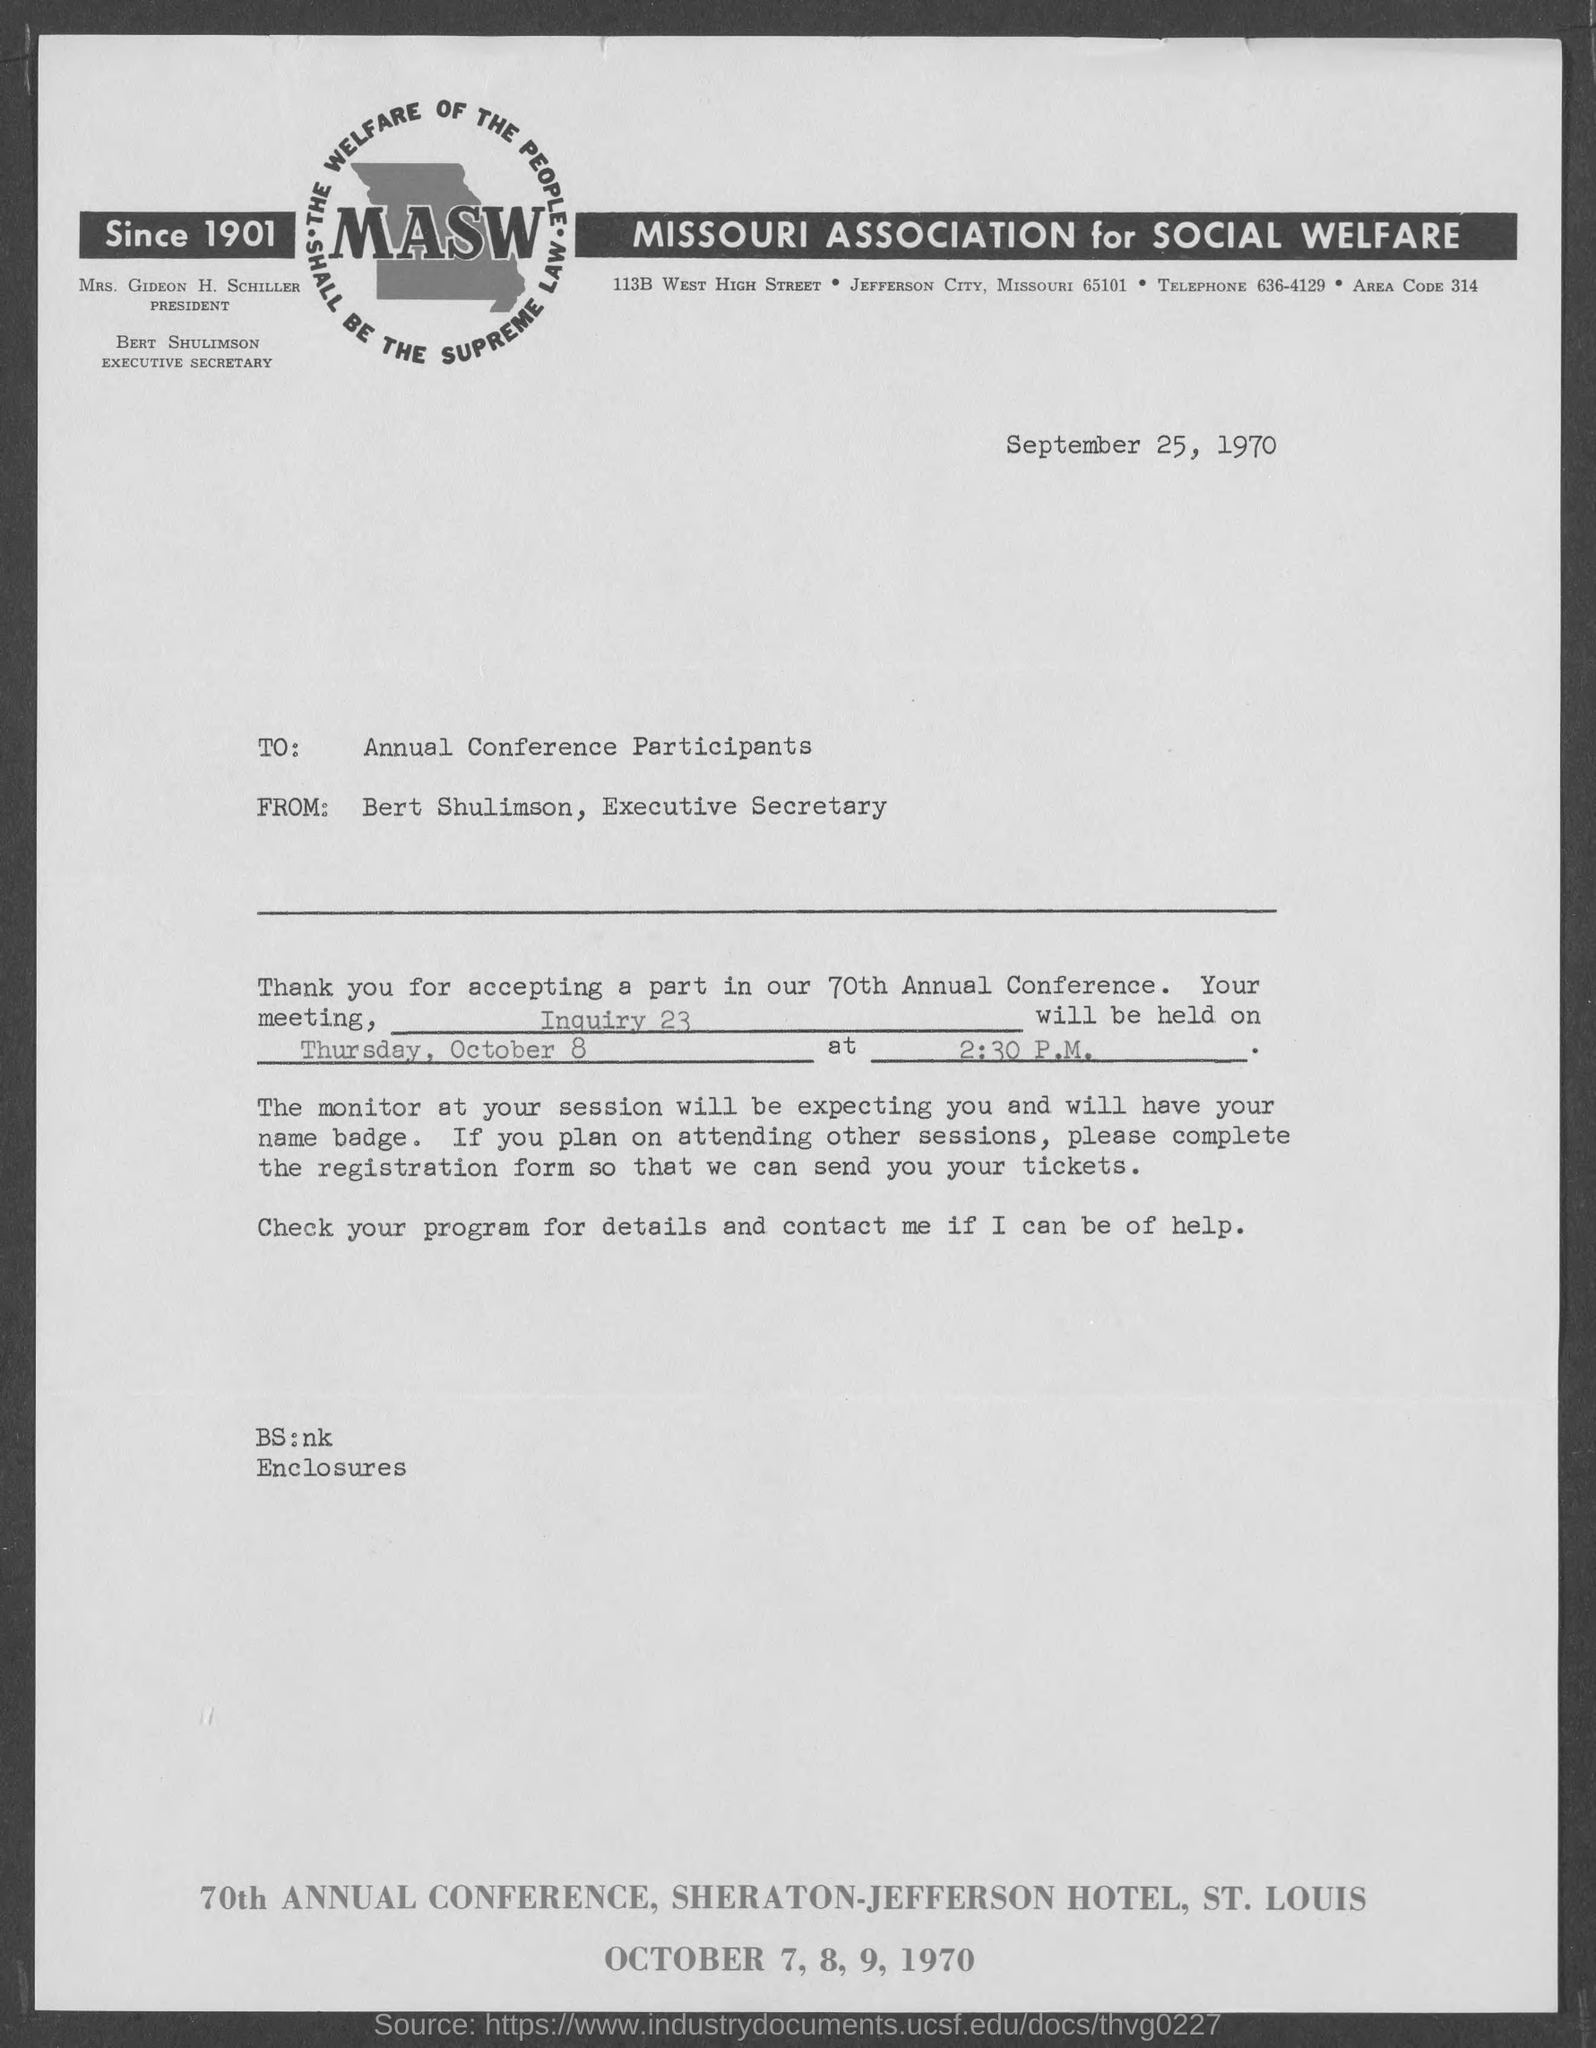Highlight a few significant elements in this photo. The fullform of MASW is the Missouri Association for Social Welfare. The executive secretary is Bert Shulimson. The date mentioned at the top of the document is September 25, 1970. 